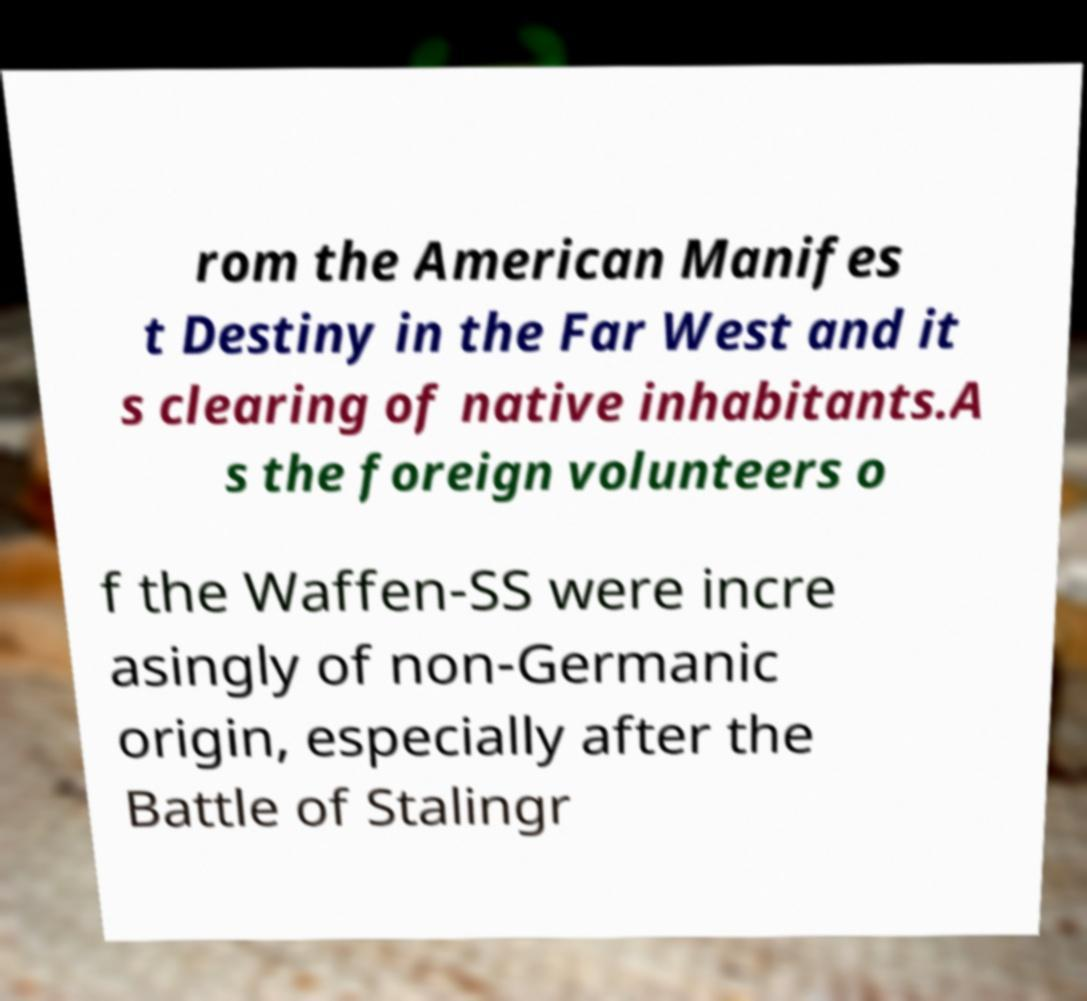For documentation purposes, I need the text within this image transcribed. Could you provide that? rom the American Manifes t Destiny in the Far West and it s clearing of native inhabitants.A s the foreign volunteers o f the Waffen-SS were incre asingly of non-Germanic origin, especially after the Battle of Stalingr 